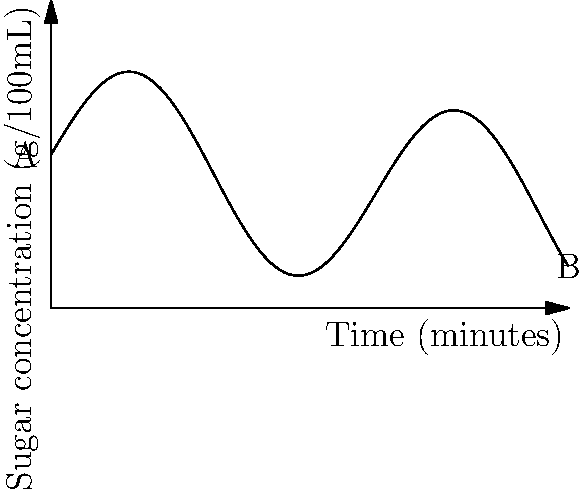The graph shows the sugar concentration in a candy syrup during a 10-minute manufacturing process. At what time, in minutes, is the rate of change of sugar concentration equal to zero? Explain your reasoning using calculus concepts. To solve this problem, we need to follow these steps:

1) The rate of change of sugar concentration is represented by the derivative of the function shown in the graph.

2) The derivative is zero when the function has a horizontal tangent line, which occurs at local maximum or minimum points.

3) From the graph, we can see that there are two points where the tangent line appears to be horizontal: one near the beginning of the process and one near the end.

4) To find the exact times, we would need the equation of the function. However, we can estimate from the graph that the first horizontal tangent occurs at approximately 1.5 minutes, and the second at approximately 8 minutes.

5) Since the question asks for a single time, we should choose the earlier instance, as it's the first time during the process that the rate of change becomes zero.

6) In calculus terms, we're looking for the time $t$ where $\frac{df}{dt} = 0$, and $f$ represents the sugar concentration function.

Therefore, based on visual estimation from the graph, the rate of change of sugar concentration is first equal to zero at approximately 1.5 minutes into the manufacturing process.
Answer: Approximately 1.5 minutes 